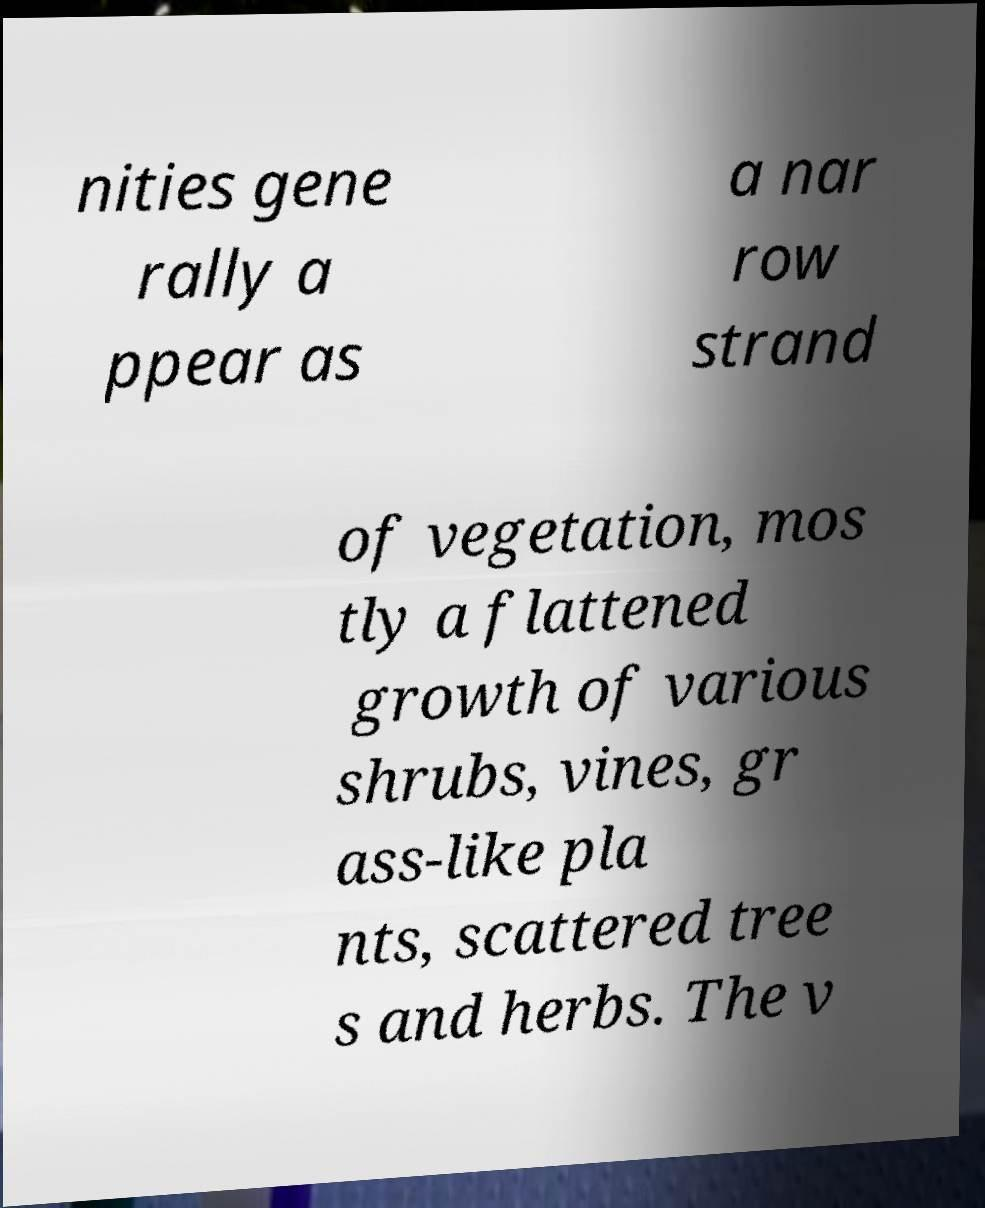What messages or text are displayed in this image? I need them in a readable, typed format. nities gene rally a ppear as a nar row strand of vegetation, mos tly a flattened growth of various shrubs, vines, gr ass-like pla nts, scattered tree s and herbs. The v 